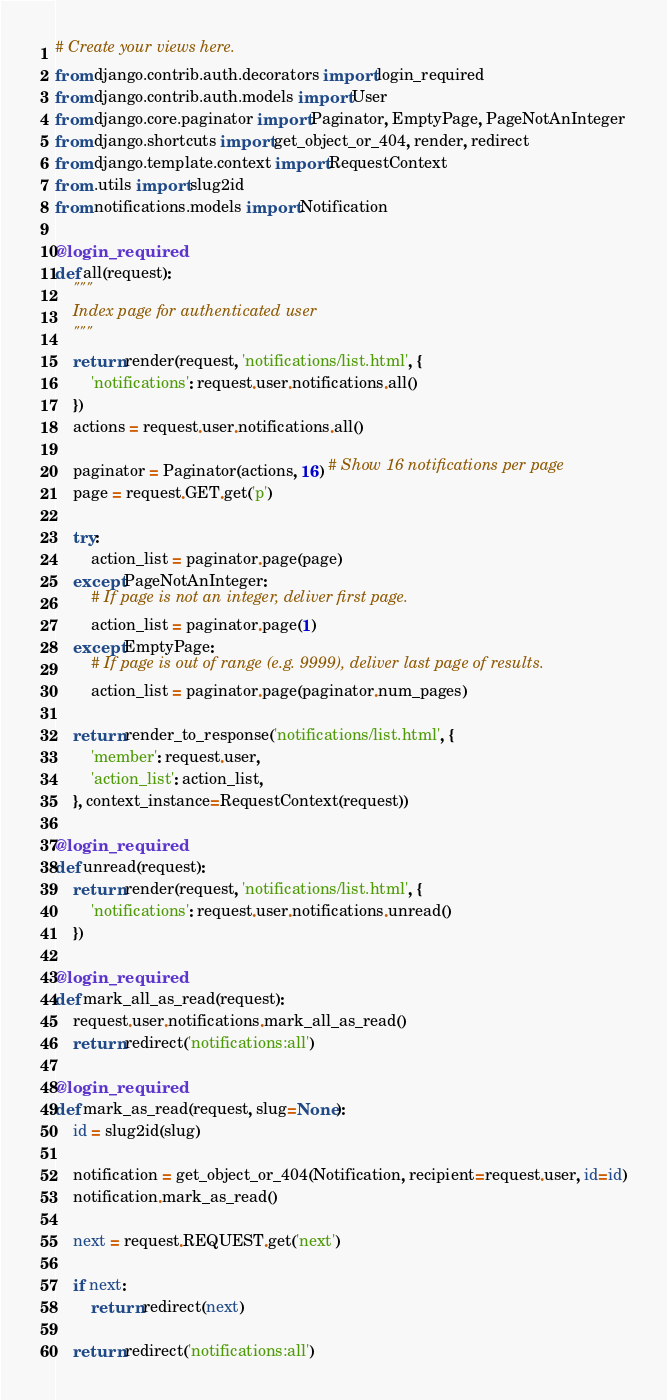Convert code to text. <code><loc_0><loc_0><loc_500><loc_500><_Python_># Create your views here.
from django.contrib.auth.decorators import login_required
from django.contrib.auth.models import User
from django.core.paginator import Paginator, EmptyPage, PageNotAnInteger
from django.shortcuts import get_object_or_404, render, redirect
from django.template.context import RequestContext
from .utils import slug2id
from notifications.models import Notification

@login_required
def all(request):
    """
    Index page for authenticated user
    """
    return render(request, 'notifications/list.html', {
        'notifications': request.user.notifications.all()
    })
    actions = request.user.notifications.all()

    paginator = Paginator(actions, 16) # Show 16 notifications per page
    page = request.GET.get('p')

    try:
        action_list = paginator.page(page)
    except PageNotAnInteger:
        # If page is not an integer, deliver first page.
        action_list = paginator.page(1)
    except EmptyPage:
        # If page is out of range (e.g. 9999), deliver last page of results.
        action_list = paginator.page(paginator.num_pages)
        
    return render_to_response('notifications/list.html', {
        'member': request.user,
        'action_list': action_list,
    }, context_instance=RequestContext(request))

@login_required
def unread(request):
    return render(request, 'notifications/list.html', {
        'notifications': request.user.notifications.unread()
    })
    
@login_required
def mark_all_as_read(request):
    request.user.notifications.mark_all_as_read()
    return redirect('notifications:all')

@login_required
def mark_as_read(request, slug=None):
    id = slug2id(slug)

    notification = get_object_or_404(Notification, recipient=request.user, id=id)
    notification.mark_as_read()

    next = request.REQUEST.get('next')

    if next:
        return redirect(next)

    return redirect('notifications:all')
</code> 